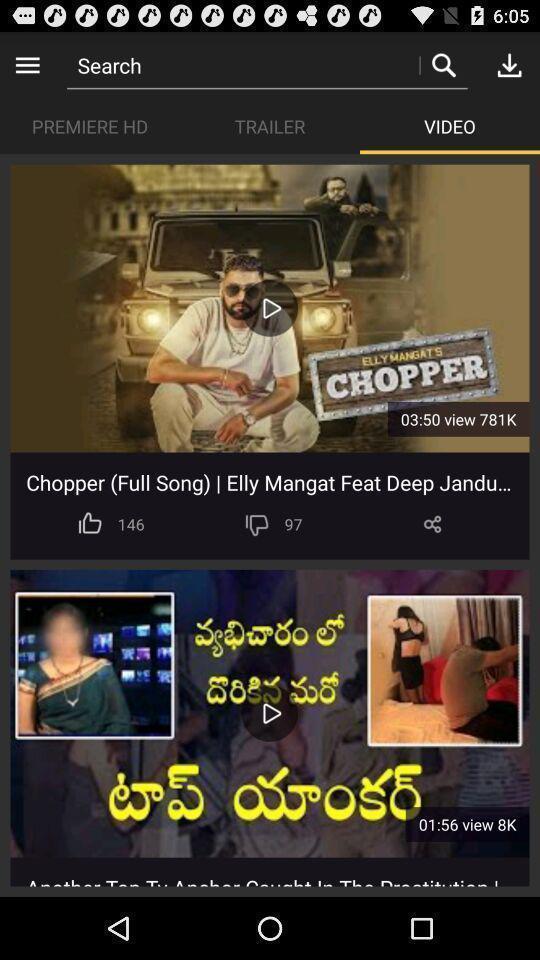Describe the key features of this screenshot. Page for searching videos in a video app. 